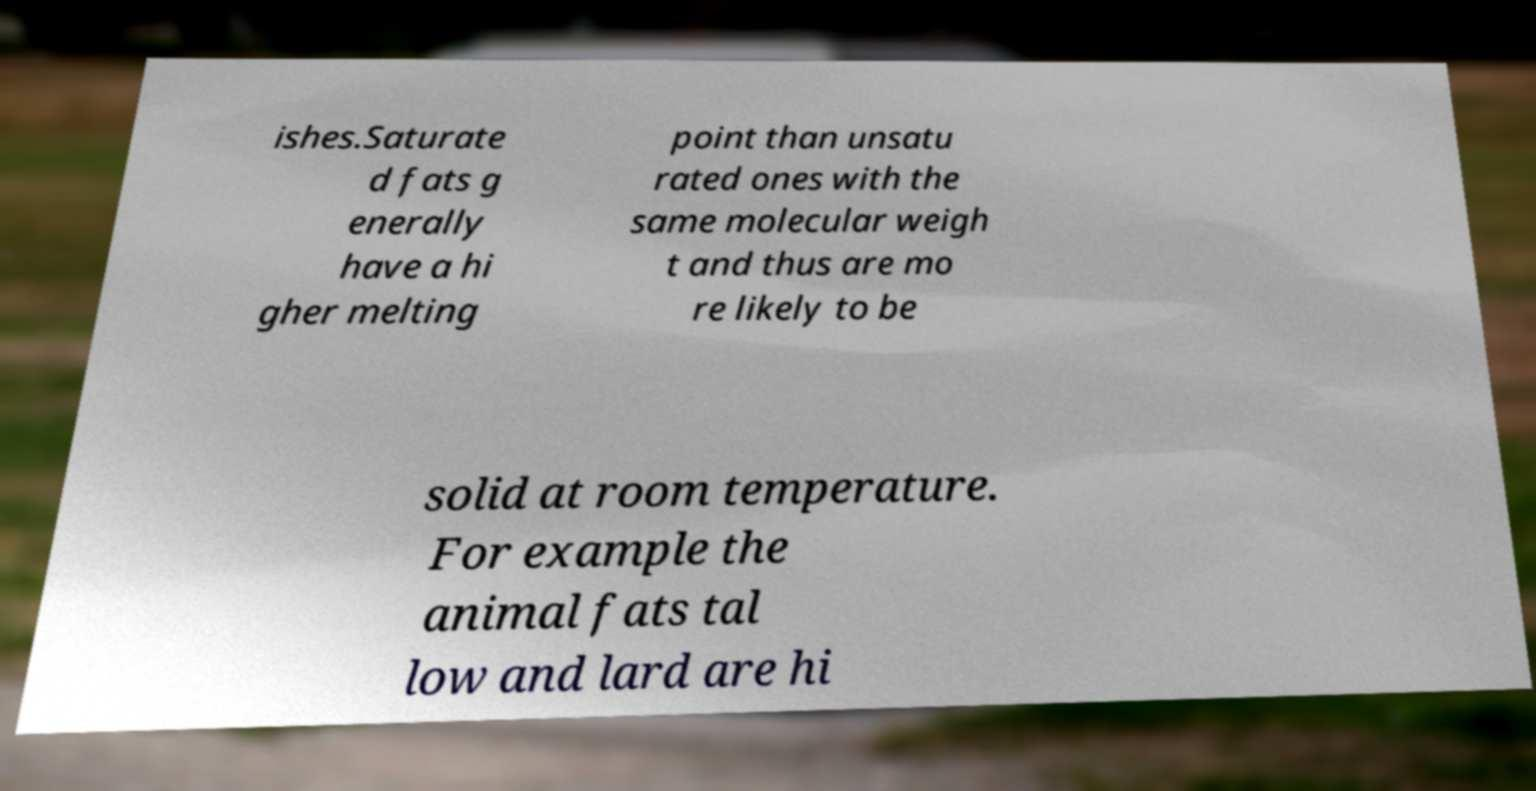What messages or text are displayed in this image? I need them in a readable, typed format. ishes.Saturate d fats g enerally have a hi gher melting point than unsatu rated ones with the same molecular weigh t and thus are mo re likely to be solid at room temperature. For example the animal fats tal low and lard are hi 